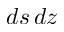Convert formula to latex. <formula><loc_0><loc_0><loc_500><loc_500>d s \, d z</formula> 